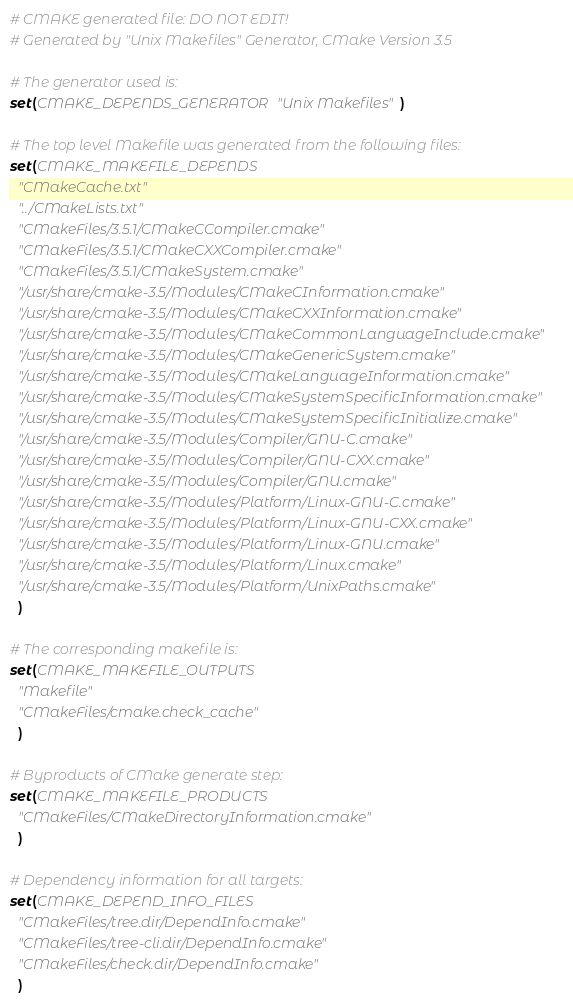<code> <loc_0><loc_0><loc_500><loc_500><_CMake_># CMAKE generated file: DO NOT EDIT!
# Generated by "Unix Makefiles" Generator, CMake Version 3.5

# The generator used is:
set(CMAKE_DEPENDS_GENERATOR "Unix Makefiles")

# The top level Makefile was generated from the following files:
set(CMAKE_MAKEFILE_DEPENDS
  "CMakeCache.txt"
  "../CMakeLists.txt"
  "CMakeFiles/3.5.1/CMakeCCompiler.cmake"
  "CMakeFiles/3.5.1/CMakeCXXCompiler.cmake"
  "CMakeFiles/3.5.1/CMakeSystem.cmake"
  "/usr/share/cmake-3.5/Modules/CMakeCInformation.cmake"
  "/usr/share/cmake-3.5/Modules/CMakeCXXInformation.cmake"
  "/usr/share/cmake-3.5/Modules/CMakeCommonLanguageInclude.cmake"
  "/usr/share/cmake-3.5/Modules/CMakeGenericSystem.cmake"
  "/usr/share/cmake-3.5/Modules/CMakeLanguageInformation.cmake"
  "/usr/share/cmake-3.5/Modules/CMakeSystemSpecificInformation.cmake"
  "/usr/share/cmake-3.5/Modules/CMakeSystemSpecificInitialize.cmake"
  "/usr/share/cmake-3.5/Modules/Compiler/GNU-C.cmake"
  "/usr/share/cmake-3.5/Modules/Compiler/GNU-CXX.cmake"
  "/usr/share/cmake-3.5/Modules/Compiler/GNU.cmake"
  "/usr/share/cmake-3.5/Modules/Platform/Linux-GNU-C.cmake"
  "/usr/share/cmake-3.5/Modules/Platform/Linux-GNU-CXX.cmake"
  "/usr/share/cmake-3.5/Modules/Platform/Linux-GNU.cmake"
  "/usr/share/cmake-3.5/Modules/Platform/Linux.cmake"
  "/usr/share/cmake-3.5/Modules/Platform/UnixPaths.cmake"
  )

# The corresponding makefile is:
set(CMAKE_MAKEFILE_OUTPUTS
  "Makefile"
  "CMakeFiles/cmake.check_cache"
  )

# Byproducts of CMake generate step:
set(CMAKE_MAKEFILE_PRODUCTS
  "CMakeFiles/CMakeDirectoryInformation.cmake"
  )

# Dependency information for all targets:
set(CMAKE_DEPEND_INFO_FILES
  "CMakeFiles/tree.dir/DependInfo.cmake"
  "CMakeFiles/tree-cli.dir/DependInfo.cmake"
  "CMakeFiles/check.dir/DependInfo.cmake"
  )
</code> 